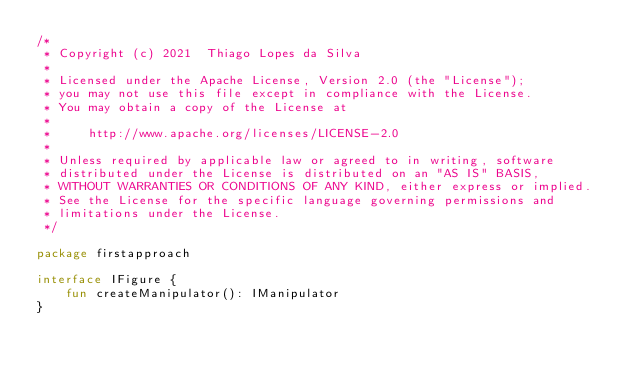<code> <loc_0><loc_0><loc_500><loc_500><_Kotlin_>/*
 * Copyright (c) 2021  Thiago Lopes da Silva
 *
 * Licensed under the Apache License, Version 2.0 (the "License");
 * you may not use this file except in compliance with the License.
 * You may obtain a copy of the License at
 *
 *     http://www.apache.org/licenses/LICENSE-2.0
 *
 * Unless required by applicable law or agreed to in writing, software
 * distributed under the License is distributed on an "AS IS" BASIS,
 * WITHOUT WARRANTIES OR CONDITIONS OF ANY KIND, either express or implied.
 * See the License for the specific language governing permissions and
 * limitations under the License.
 */

package firstapproach

interface IFigure {
    fun createManipulator(): IManipulator
}</code> 